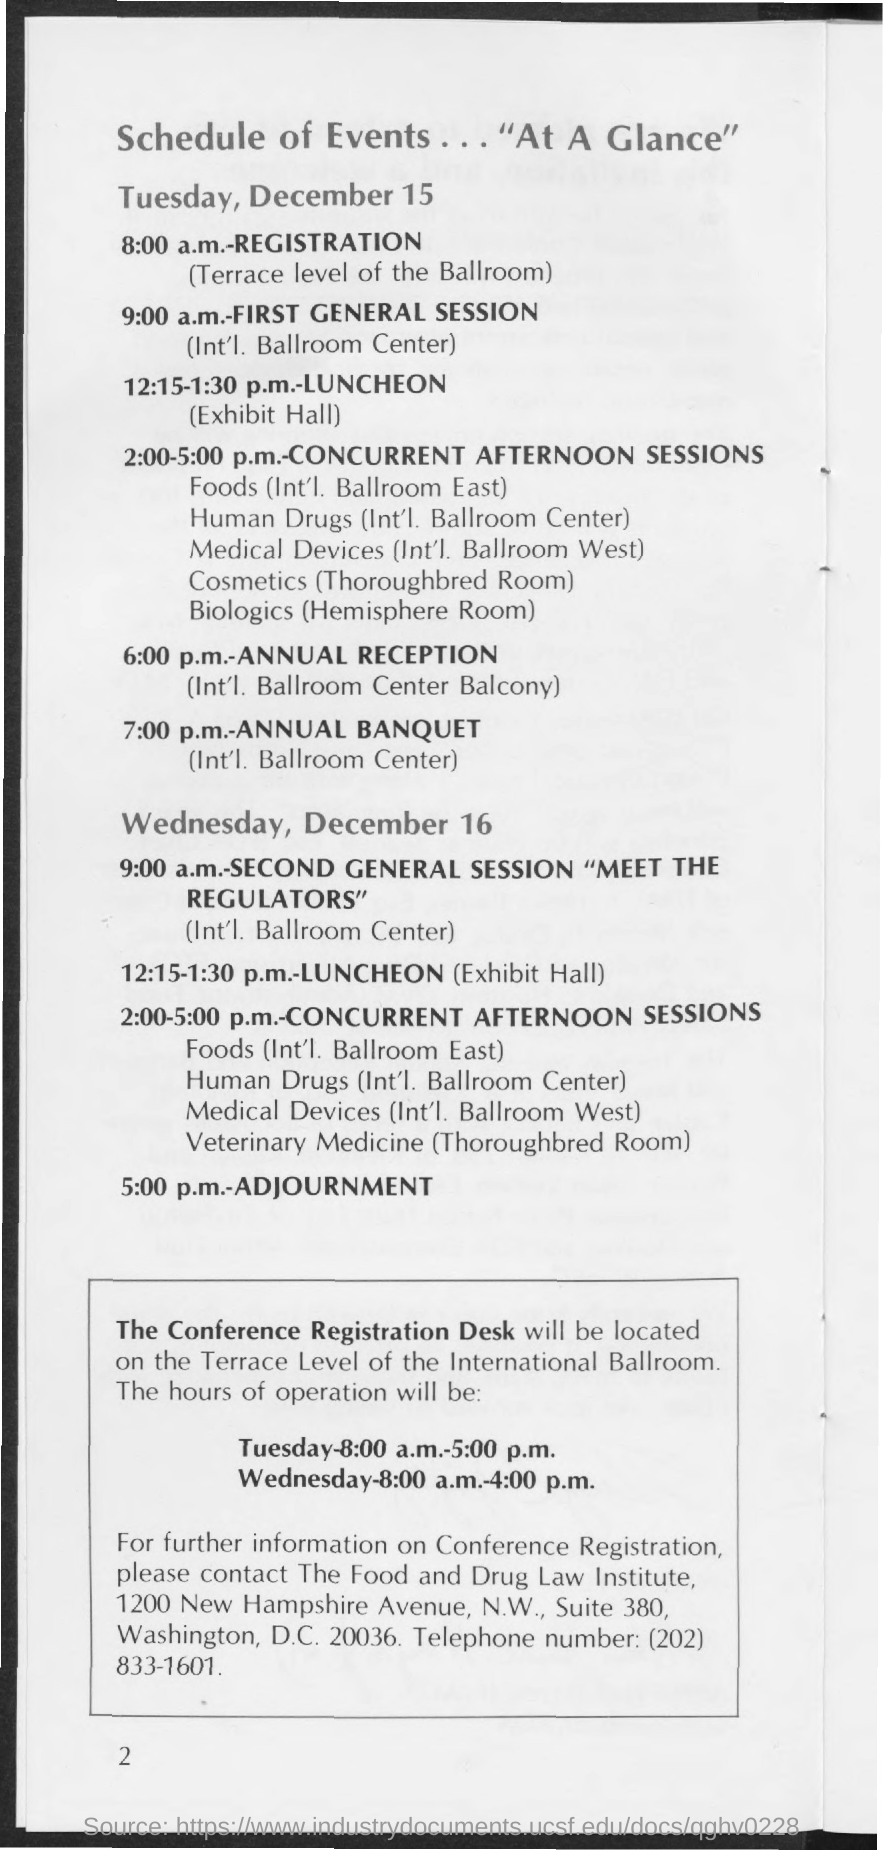What is the postal address of the food and drug law institute ?
Keep it short and to the point. 1200 New Hampshire Avenue, N.W., Suite 380, Washington, D.C. 20036. What is the time scheduled for registration on tuesday, december 15?
Your answer should be compact. 8:00 a.m. What is the venue for registration on tuesday, december 15?
Provide a short and direct response. Terrace level of the Ballroom. What is the time scheduled for first general session on tuesday, december 15?
Offer a very short reply. 9:00 a.m. What is venue for first general session on tuesday, december 15?
Your answer should be very brief. Int'l. Ballroom Center. 